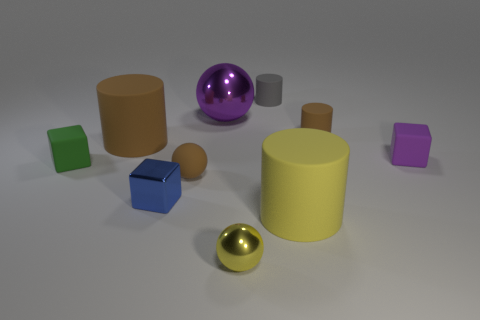There is a rubber cylinder that is in front of the green block; is there a small cylinder on the left side of it?
Keep it short and to the point. Yes. There is a brown matte thing to the left of the brown rubber sphere; is its shape the same as the small metallic object that is to the left of the brown sphere?
Your response must be concise. No. Are the purple thing on the left side of the small gray matte cylinder and the blue thing that is behind the yellow metal thing made of the same material?
Ensure brevity in your answer.  Yes. What material is the green cube behind the cylinder that is in front of the small blue thing made of?
Offer a very short reply. Rubber. What shape is the small brown thing that is behind the tiny purple rubber cube on the right side of the shiny object behind the tiny green cube?
Give a very brief answer. Cylinder. There is a purple object that is the same shape as the tiny yellow object; what is its material?
Ensure brevity in your answer.  Metal. What number of cyan rubber things are there?
Provide a succinct answer. 0. The small brown thing that is behind the big brown matte cylinder has what shape?
Ensure brevity in your answer.  Cylinder. What color is the block in front of the small matte object that is on the left side of the tiny metal object that is to the left of the large purple thing?
Make the answer very short. Blue. What shape is the tiny gray thing that is made of the same material as the green block?
Make the answer very short. Cylinder. 